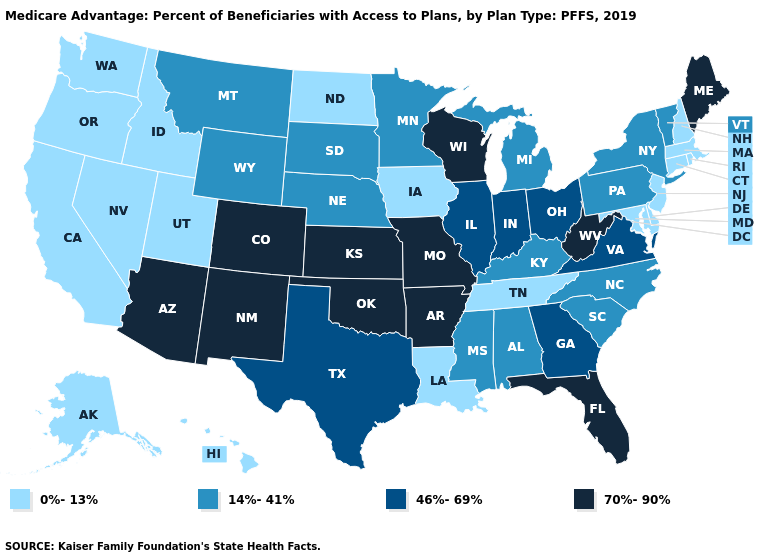What is the lowest value in the USA?
Concise answer only. 0%-13%. What is the value of Oklahoma?
Quick response, please. 70%-90%. Does the map have missing data?
Give a very brief answer. No. Name the states that have a value in the range 14%-41%?
Concise answer only. Alabama, Kentucky, Michigan, Minnesota, Mississippi, Montana, Nebraska, New York, North Carolina, Pennsylvania, South Carolina, South Dakota, Vermont, Wyoming. What is the lowest value in the West?
Short answer required. 0%-13%. Name the states that have a value in the range 46%-69%?
Keep it brief. Georgia, Illinois, Indiana, Ohio, Texas, Virginia. What is the lowest value in the USA?
Write a very short answer. 0%-13%. What is the value of Illinois?
Keep it brief. 46%-69%. Does Missouri have the highest value in the MidWest?
Short answer required. Yes. Name the states that have a value in the range 0%-13%?
Quick response, please. Alaska, California, Connecticut, Delaware, Hawaii, Idaho, Iowa, Louisiana, Maryland, Massachusetts, Nevada, New Hampshire, New Jersey, North Dakota, Oregon, Rhode Island, Tennessee, Utah, Washington. What is the value of New Hampshire?
Write a very short answer. 0%-13%. Among the states that border Michigan , does Indiana have the highest value?
Be succinct. No. Does the map have missing data?
Keep it brief. No. Name the states that have a value in the range 0%-13%?
Concise answer only. Alaska, California, Connecticut, Delaware, Hawaii, Idaho, Iowa, Louisiana, Maryland, Massachusetts, Nevada, New Hampshire, New Jersey, North Dakota, Oregon, Rhode Island, Tennessee, Utah, Washington. Is the legend a continuous bar?
Be succinct. No. 